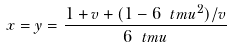Convert formula to latex. <formula><loc_0><loc_0><loc_500><loc_500>x = y = \frac { 1 + v + ( 1 - 6 \ t m u ^ { 2 } ) / v } { 6 \ t m u }</formula> 